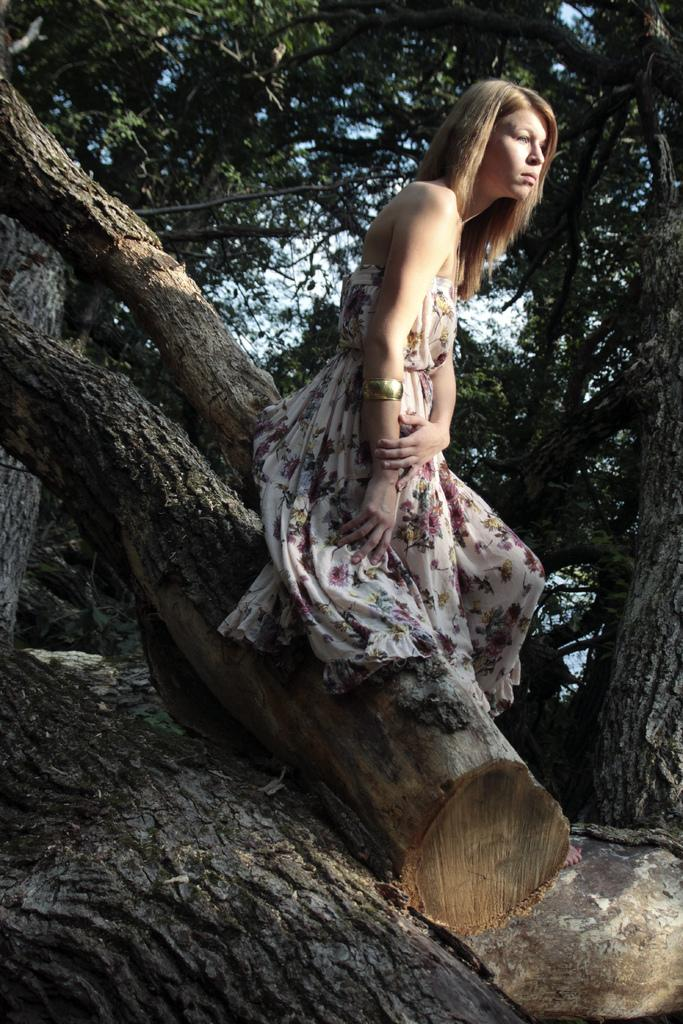Who is the main subject in the image? There is a woman in the middle of the image. What can be seen in the background of the image? There are trees and the sky visible in the background of the image. Can you describe the tree bark on the left side of the image? Yes, there is tree bark on the left side of the image. What type of vase is being used to hold the woman's debt in the image? There is no vase or mention of debt present in the image. 